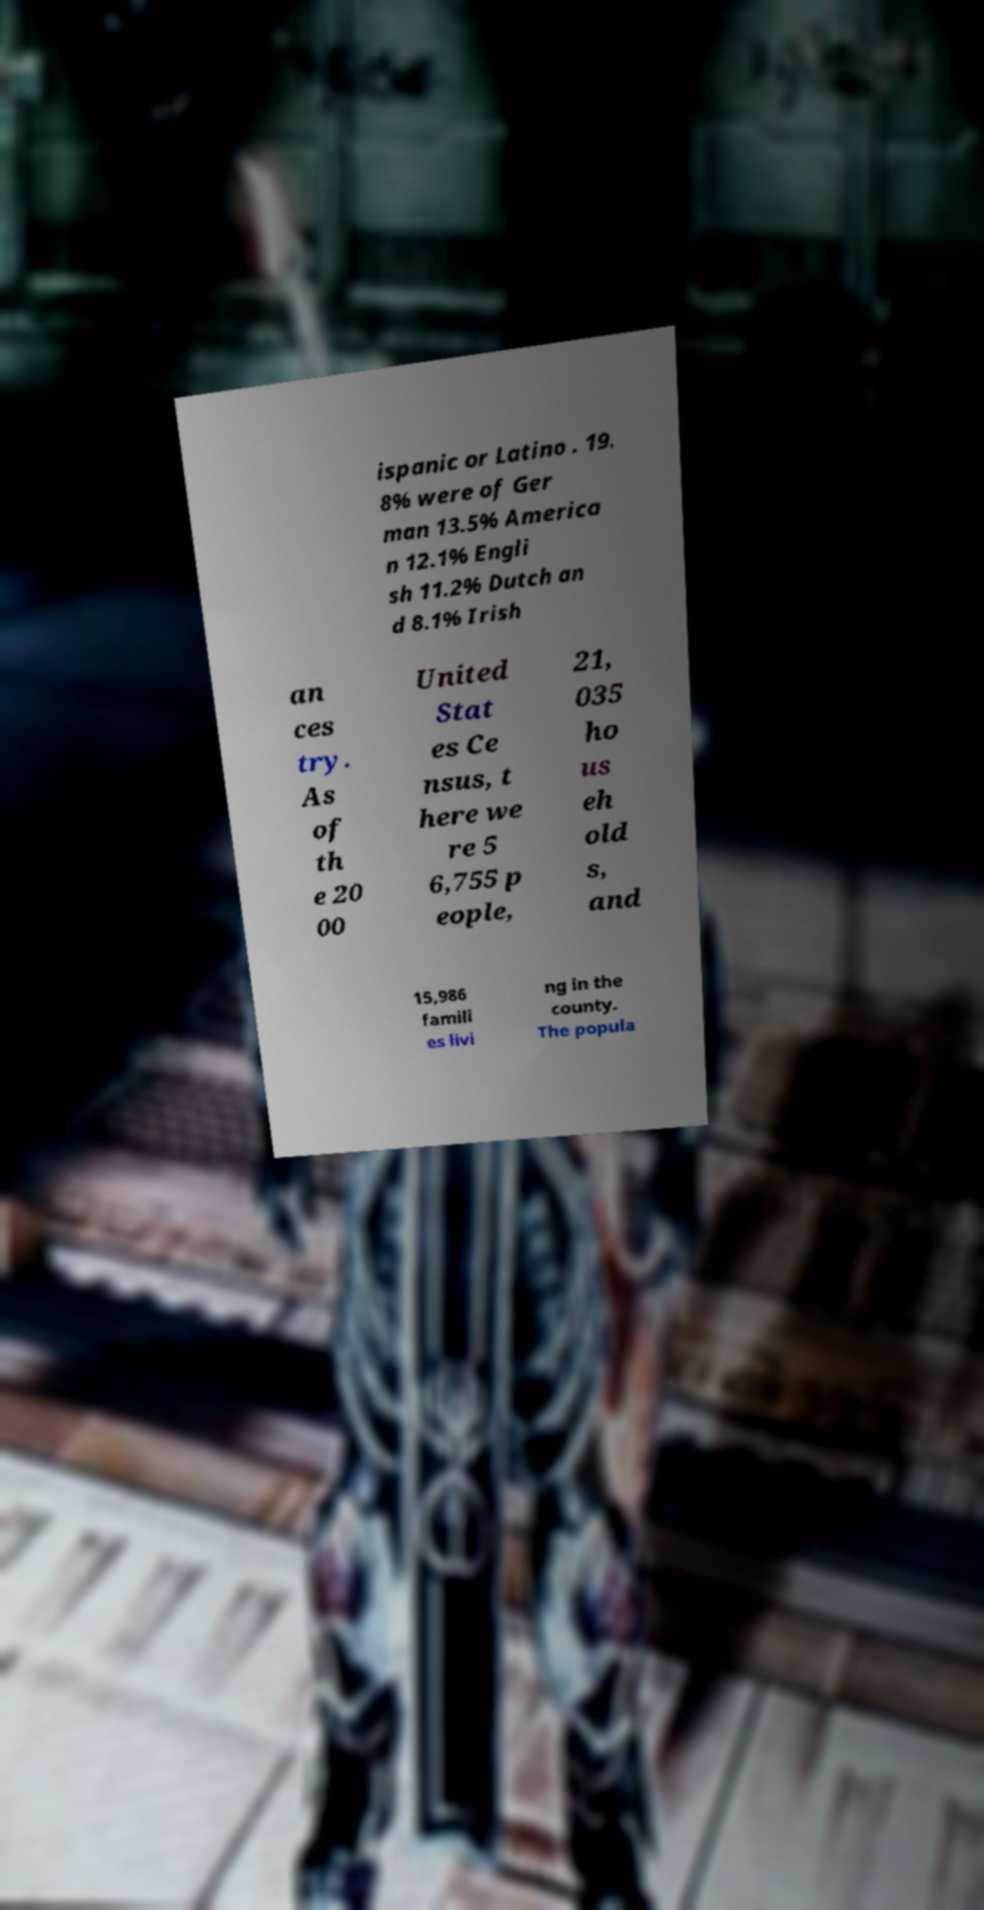Please identify and transcribe the text found in this image. ispanic or Latino . 19. 8% were of Ger man 13.5% America n 12.1% Engli sh 11.2% Dutch an d 8.1% Irish an ces try. As of th e 20 00 United Stat es Ce nsus, t here we re 5 6,755 p eople, 21, 035 ho us eh old s, and 15,986 famili es livi ng in the county. The popula 